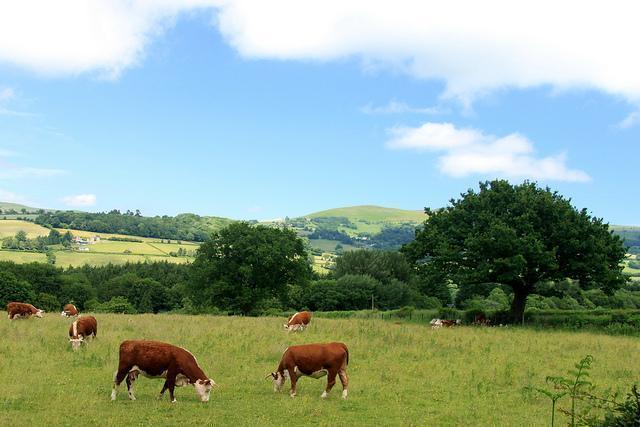These animals usually live where?
From the following four choices, select the correct answer to address the question.
Options: Cave, underground hole, pasture, tundra. Pasture. 